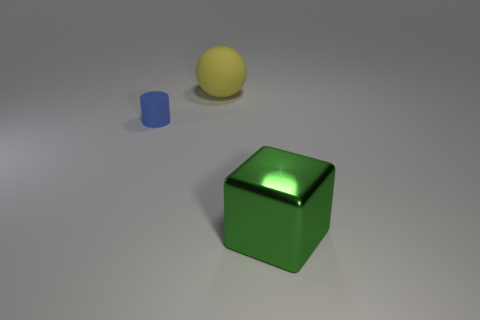Add 2 brown shiny things. How many objects exist? 5 Subtract all cubes. How many objects are left? 2 Add 1 green cubes. How many green cubes exist? 2 Subtract 0 cyan cylinders. How many objects are left? 3 Subtract 1 cylinders. How many cylinders are left? 0 Subtract all cyan cylinders. Subtract all yellow balls. How many cylinders are left? 1 Subtract all small gray matte cylinders. Subtract all blue cylinders. How many objects are left? 2 Add 2 cubes. How many cubes are left? 3 